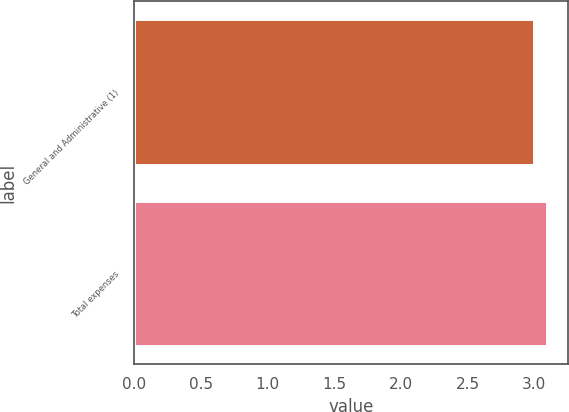<chart> <loc_0><loc_0><loc_500><loc_500><bar_chart><fcel>General and Administrative (1)<fcel>Total expenses<nl><fcel>3<fcel>3.1<nl></chart> 